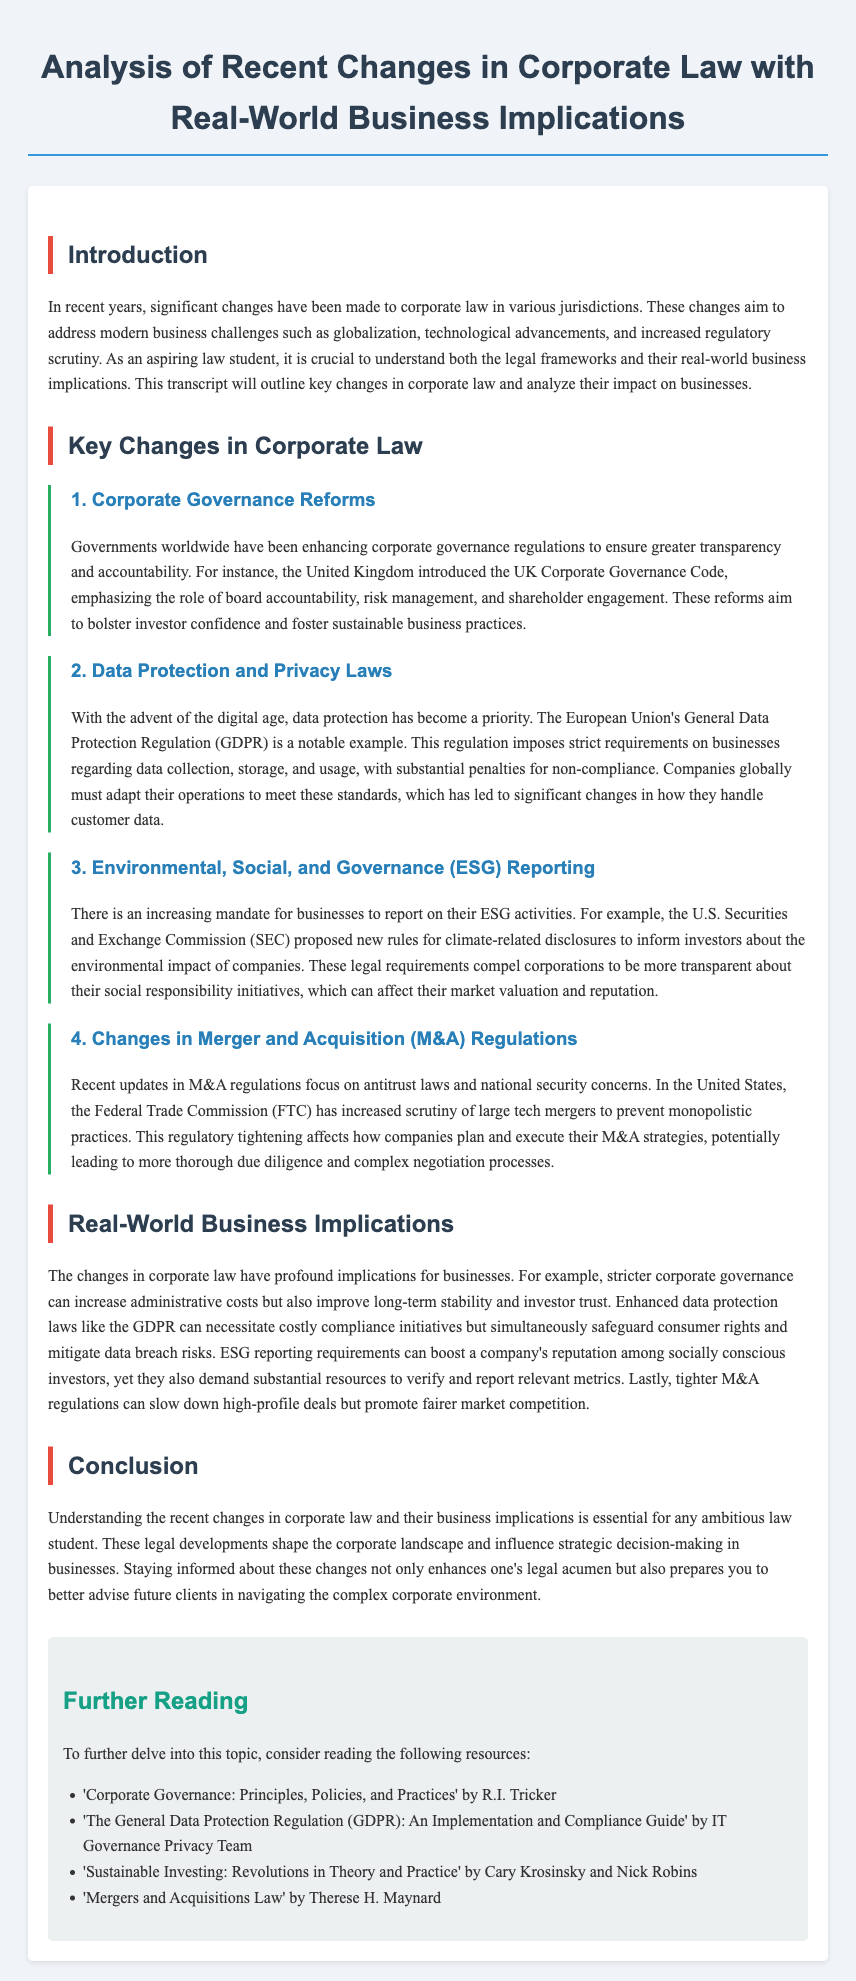what regulation did the UK introduce? The UK introduced the UK Corporate Governance Code to enhance corporate governance regulations.
Answer: UK Corporate Governance Code what does GDPR stand for? GDPR stands for the General Data Protection Regulation.
Answer: General Data Protection Regulation which commission proposed new rules for ESG reporting? The U.S. Securities and Exchange Commission proposed new rules for climate-related disclosures.
Answer: U.S. Securities and Exchange Commission what is a consequence of tighter M&A regulations? Tighter M&A regulations can slow down high-profile deals but promote fairer market competition.
Answer: Slow down high-profile deals what is one impact of enhanced data protection laws? Enhanced data protection laws necessitate costly compliance initiatives for businesses.
Answer: Costly compliance initiatives which two areas do corporate governance reforms focus on? Corporate governance reforms focus on board accountability and risk management.
Answer: Board accountability, risk management how has the Federal Trade Commission responded to large tech mergers? The Federal Trade Commission has increased scrutiny of large tech mergers to prevent monopolistic practices.
Answer: Increased scrutiny what do stricter corporate governance regulations aim to improve? Stricter corporate governance regulations aim to bolster investor confidence and foster sustainable business practices.
Answer: Investor confidence what is the overarching theme of the document? The overarching theme of the document is the analysis of recent changes in corporate law and their business implications.
Answer: Changes in corporate law and business implications 